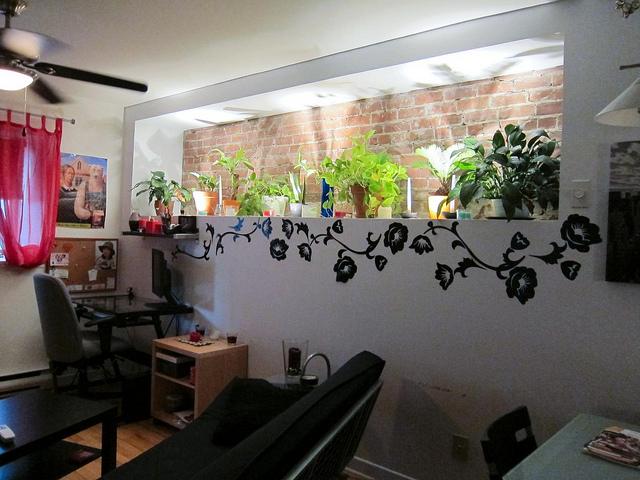What time of year is it?
Write a very short answer. Summer. What color are the curtains?
Quick response, please. Red. How many plants are in this room?
Give a very brief answer. 7. Is the plant a spider plant?
Short answer required. No. How many lights are in the ceiling?
Short answer required. 1. What is the stencil of on the walls?
Answer briefly. Flowers. Does the plant need to be watered?
Quick response, please. No. 